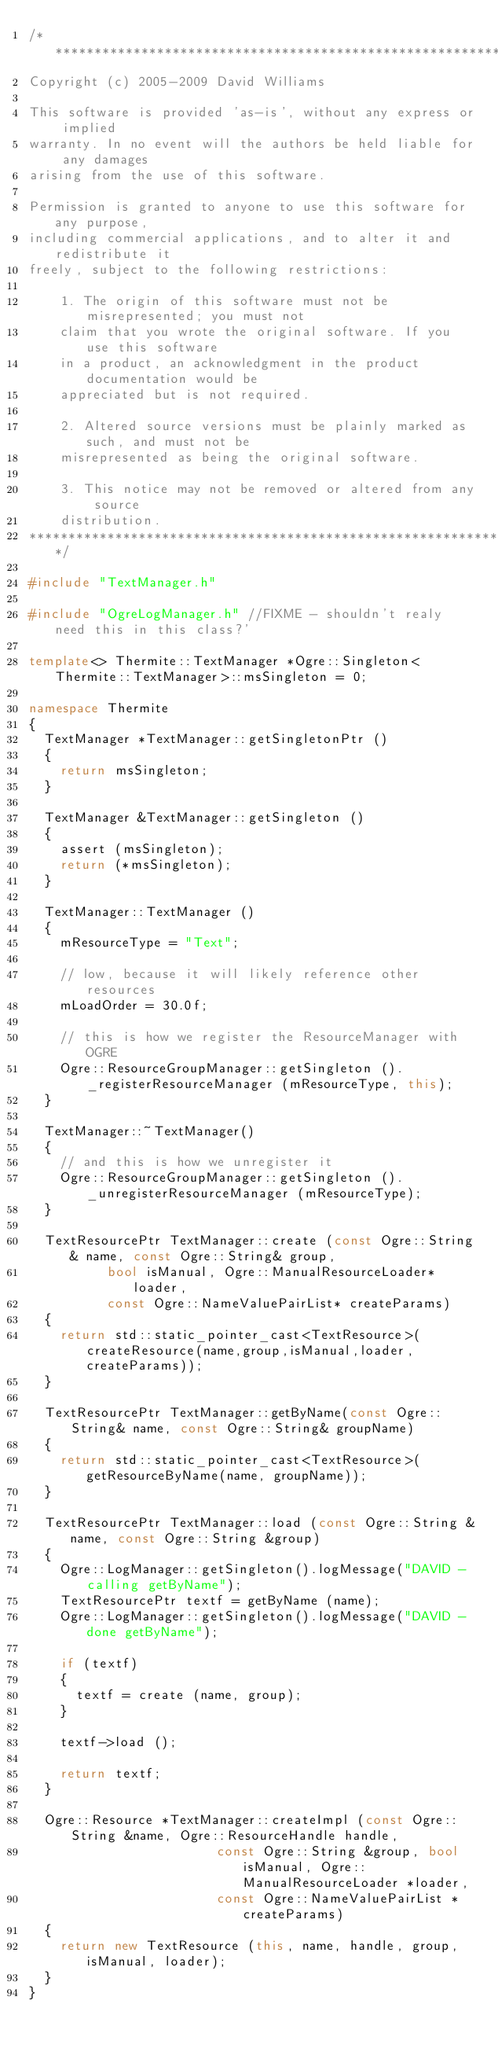Convert code to text. <code><loc_0><loc_0><loc_500><loc_500><_C++_>/*******************************************************************************
Copyright (c) 2005-2009 David Williams

This software is provided 'as-is', without any express or implied
warranty. In no event will the authors be held liable for any damages
arising from the use of this software.

Permission is granted to anyone to use this software for any purpose,
including commercial applications, and to alter it and redistribute it
freely, subject to the following restrictions:

    1. The origin of this software must not be misrepresented; you must not
    claim that you wrote the original software. If you use this software
    in a product, an acknowledgment in the product documentation would be
    appreciated but is not required.

    2. Altered source versions must be plainly marked as such, and must not be
    misrepresented as being the original software.

    3. This notice may not be removed or altered from any source
    distribution. 
*******************************************************************************/

#include "TextManager.h"

#include "OgreLogManager.h" //FIXME - shouldn't realy need this in this class?'

template<> Thermite::TextManager *Ogre::Singleton<Thermite::TextManager>::msSingleton = 0;

namespace Thermite
{
	TextManager *TextManager::getSingletonPtr ()
	{
		return msSingleton;
	}

	TextManager &TextManager::getSingleton ()
	{  
		assert (msSingleton);  
		return (*msSingleton);
	}

	TextManager::TextManager ()
	{
		mResourceType = "Text";

		// low, because it will likely reference other resources
		mLoadOrder = 30.0f;

		// this is how we register the ResourceManager with OGRE
		Ogre::ResourceGroupManager::getSingleton ()._registerResourceManager (mResourceType, this);
	}

	TextManager::~TextManager()
	{
		// and this is how we unregister it
		Ogre::ResourceGroupManager::getSingleton ()._unregisterResourceManager (mResourceType);
	}

	TextResourcePtr TextManager::create (const Ogre::String& name, const Ogre::String& group,
					bool isManual, Ogre::ManualResourceLoader* loader,
					const Ogre::NameValuePairList* createParams)
	{
		return std::static_pointer_cast<TextResource>(createResource(name,group,isManual,loader,createParams));
	}

	TextResourcePtr TextManager::getByName(const Ogre::String& name, const Ogre::String& groupName)
	{
		return std::static_pointer_cast<TextResource>(getResourceByName(name, groupName));
	}

	TextResourcePtr TextManager::load (const Ogre::String &name, const Ogre::String &group)
	{
		Ogre::LogManager::getSingleton().logMessage("DAVID - calling getByName");
		TextResourcePtr textf = getByName (name);
		Ogre::LogManager::getSingleton().logMessage("DAVID - done getByName");

		if (textf)
		{
			textf = create (name, group);
		}

		textf->load ();

		return textf;
	}

	Ogre::Resource *TextManager::createImpl (const Ogre::String &name, Ogre::ResourceHandle handle, 
												const Ogre::String &group, bool isManual, Ogre::ManualResourceLoader *loader, 
												const Ogre::NameValuePairList *createParams)
	{
		return new TextResource (this, name, handle, group, isManual, loader);
	}
}</code> 